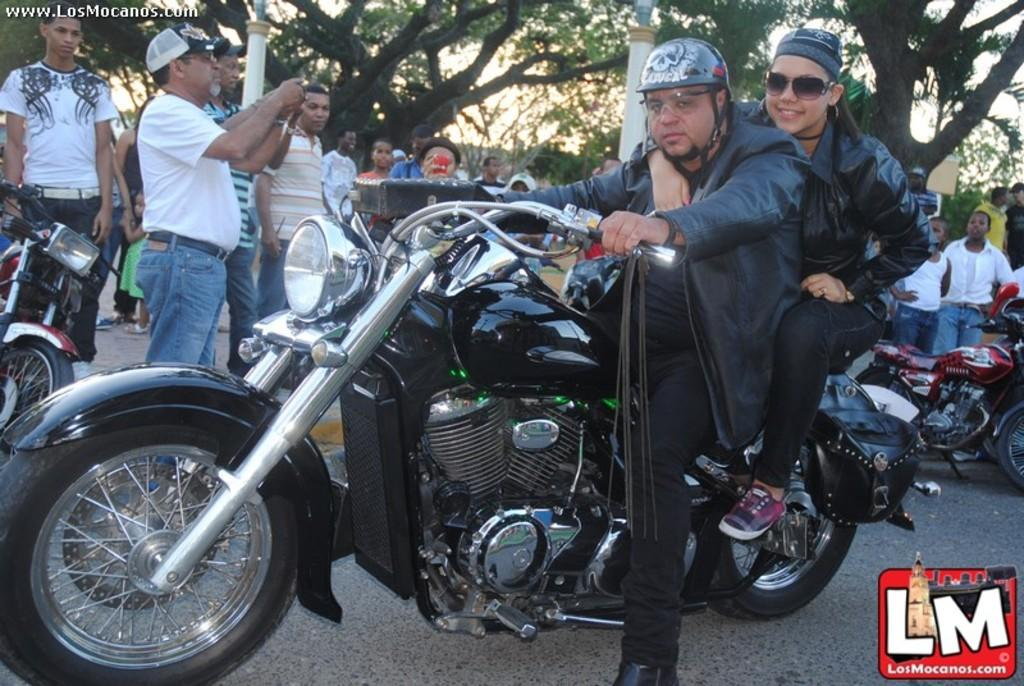What are the people doing in the image? There are people sitting on a bike in the image. What type of vehicles are visible in the image? There are motorbikes visible in the image. What are the people near the motorbikes doing? There are people standing near the motorbikes. What can be seen in the background of the image? There are trees visible in the background. What type of nail is being used to fix the motorbike in the image? There is no nail visible in the image, nor is there any indication that a motorbike is being fixed. 